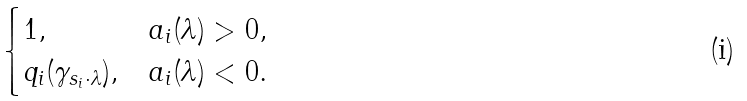Convert formula to latex. <formula><loc_0><loc_0><loc_500><loc_500>\begin{cases} 1 , & a _ { i } ( \lambda ) > 0 , \\ q _ { i } ( \gamma _ { s _ { i } \cdot \lambda } ) , & a _ { i } ( \lambda ) < 0 . \end{cases}</formula> 